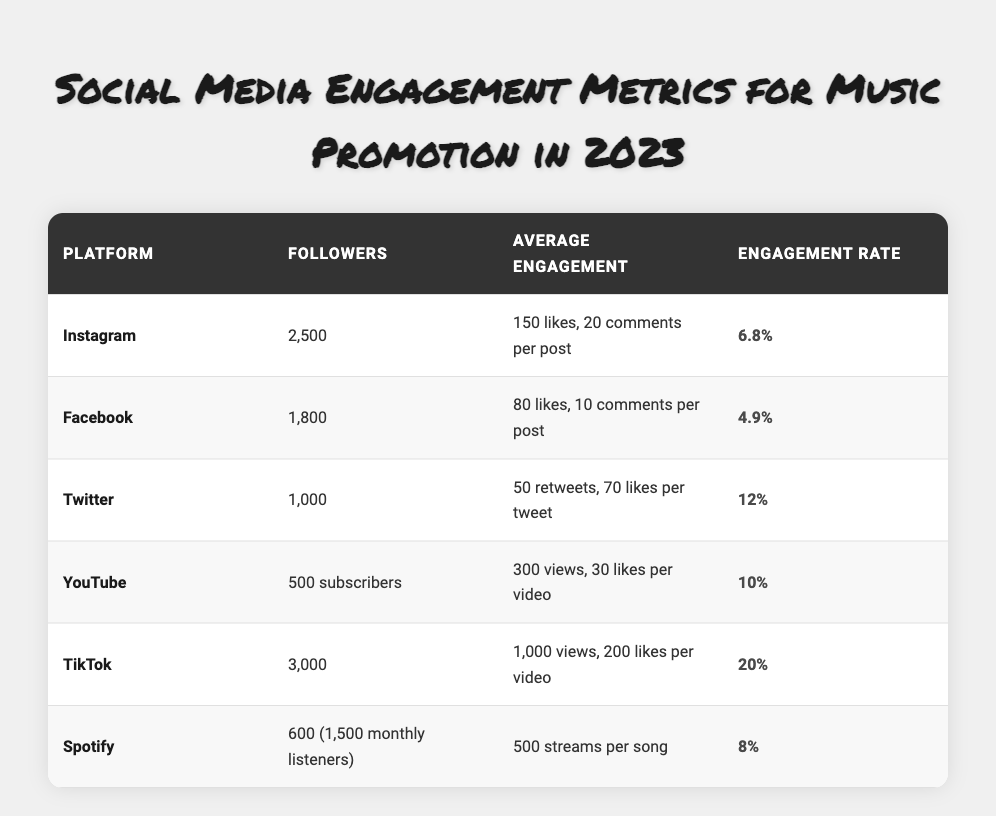What is the engagement rate for TikTok? The engagement rate for TikTok is clearly listed in the table as 20%.
Answer: 20% Which platform has the highest average likes per post? Looking at the average likes per post, TikTok has 200 likes, Instagram has 150 likes, Facebook has 80 likes, and the others are lower. Therefore, TikTok has the highest average likes per post.
Answer: TikTok How many followers does YouTube have? The table indicates that YouTube has 500 subscribers listed under followers.
Answer: 500 What is the total number of followers across all platforms? Adding the followers from each platform: Instagram (2500) + Facebook (1800) + Twitter (1000) + YouTube (500) + TikTok (3000) + Spotify (600) gives a total of 2500 + 1800 + 1000 + 500 + 3000 + 600 = 10400.
Answer: 10400 Is the engagement rate for Facebook higher than that for Spotify? Facebook has an engagement rate of 4.9% and Spotify has an engagement rate of 8%. Since 4.9% is less than 8%, Facebook's engagement rate is not higher than Spotify's.
Answer: No What is the average engagement rate of the top three platforms? The top three platforms by engagement rate are TikTok (20%), Twitter (12%), and YouTube (10%). To find the average: (20% + 12% + 10%) / 3 = 42% / 3 = 14%.
Answer: 14% Which platform has the lowest number of average likes or engagement per post? From the data, Facebook has the lowest average likes per post (80) and average engagement (80 likes + 10 comments = 90 total engagements). Hence, it has the lowest.
Answer: Facebook Does Twitter have more followers than Instagram? Twitter has 1000 followers whereas Instagram has 2500 followers. Since 1000 is less than 2500, Twitter does not have more followers.
Answer: No What is the average number of streams per song on Spotify? The table shows that Spotify has an average of 500 streams per song listed under average engagement, which is straightforward.
Answer: 500 Which platform has the lowest engagement rate? From the engagement rates listed, Facebook has the lowest rate at 4.9%, compared to others like Instagram (6.8%), Spotify (8%), Twitter (12%), YouTube (10%), and TikTok (20%).
Answer: Facebook 